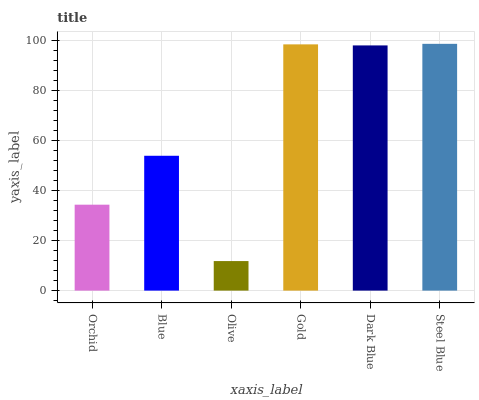Is Olive the minimum?
Answer yes or no. Yes. Is Steel Blue the maximum?
Answer yes or no. Yes. Is Blue the minimum?
Answer yes or no. No. Is Blue the maximum?
Answer yes or no. No. Is Blue greater than Orchid?
Answer yes or no. Yes. Is Orchid less than Blue?
Answer yes or no. Yes. Is Orchid greater than Blue?
Answer yes or no. No. Is Blue less than Orchid?
Answer yes or no. No. Is Dark Blue the high median?
Answer yes or no. Yes. Is Blue the low median?
Answer yes or no. Yes. Is Steel Blue the high median?
Answer yes or no. No. Is Dark Blue the low median?
Answer yes or no. No. 